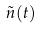Convert formula to latex. <formula><loc_0><loc_0><loc_500><loc_500>\tilde { n } ( t )</formula> 